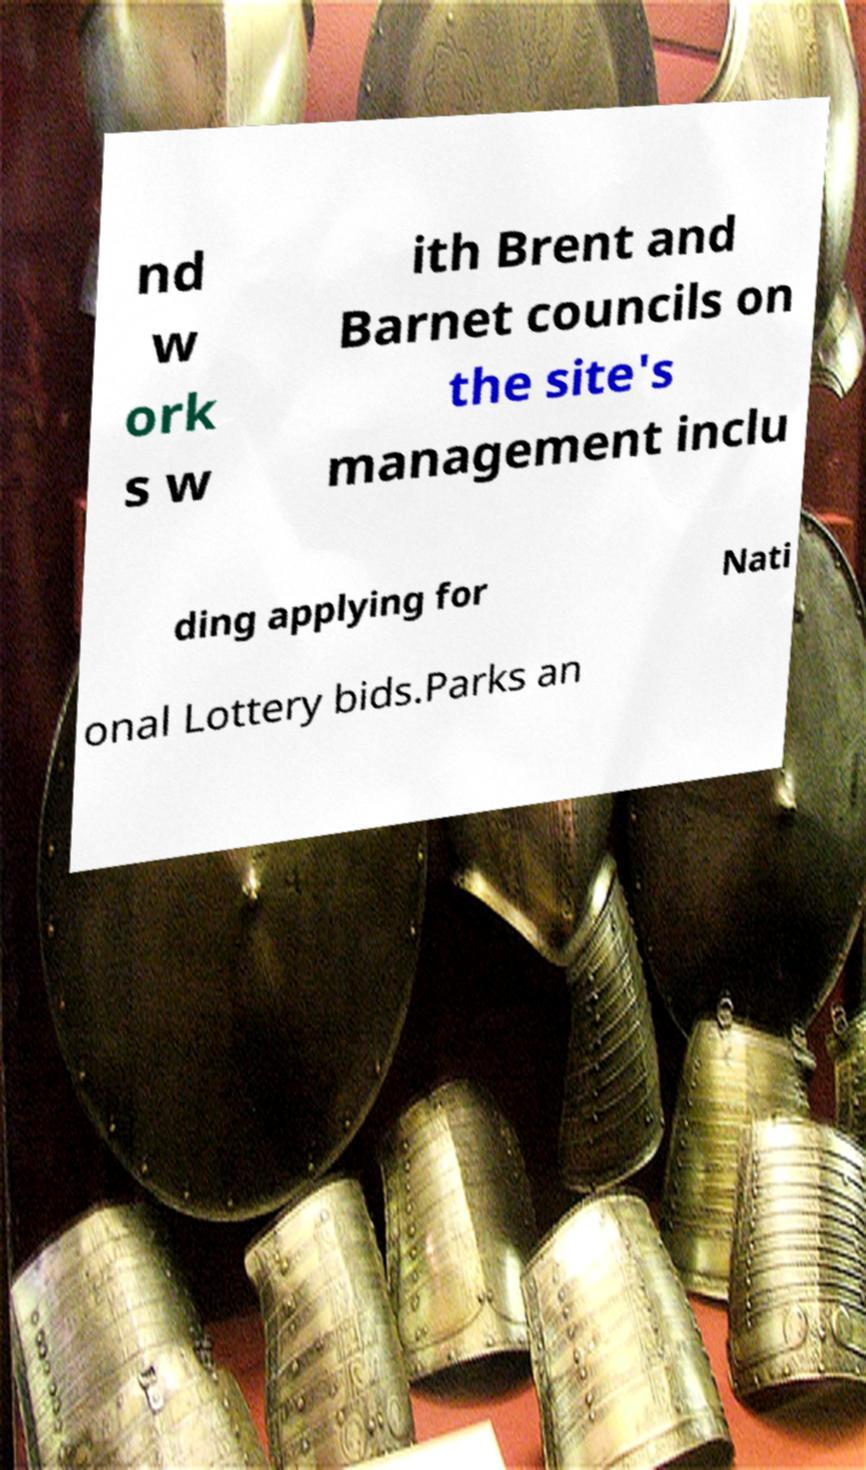Please read and relay the text visible in this image. What does it say? nd w ork s w ith Brent and Barnet councils on the site's management inclu ding applying for Nati onal Lottery bids.Parks an 